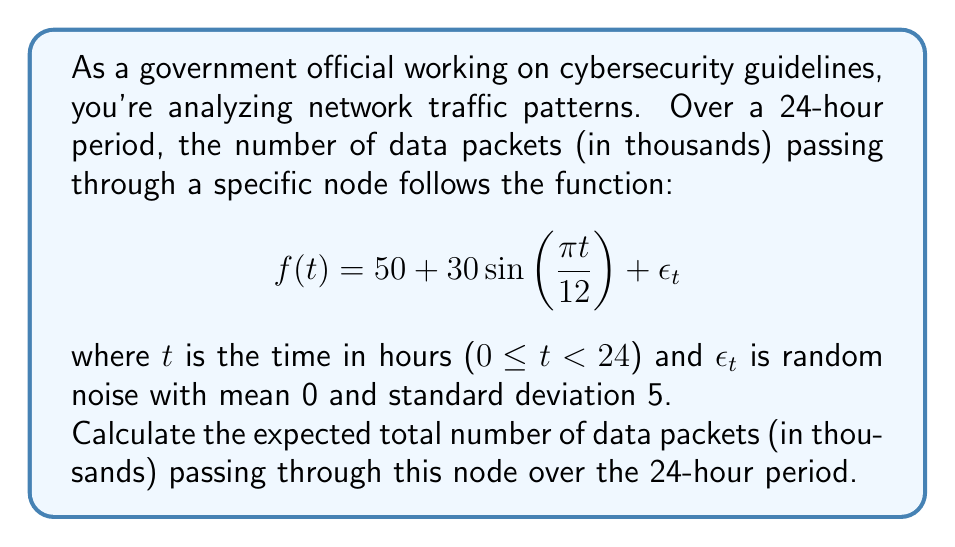Can you solve this math problem? To solve this problem, we need to integrate the function $f(t)$ over the 24-hour period, excluding the random noise term $\epsilon_t$ as its expected value is 0.

1) First, let's consider the integral of $f(t)$ without the noise term:

   $$\int_0^{24} (50 + 30\sin(\frac{\pi t}{12})) dt$$

2) We can split this into two integrals:

   $$\int_0^{24} 50 dt + \int_0^{24} 30\sin(\frac{\pi t}{12}) dt$$

3) The first integral is straightforward:

   $$50 \cdot 24 = 1200$$

4) For the second integral, we use the substitution $u = \frac{\pi t}{12}$:

   $$\frac{360}{\pi} \int_0^{2\pi} \sin(u) du$$

5) We know that $\int \sin(u) du = -\cos(u) + C$, so:

   $$\frac{360}{\pi} [-\cos(u)]_0^{2\pi} = \frac{360}{\pi} [-\cos(2\pi) + \cos(0)] = 0$$

6) Therefore, the total integral is simply 1200.

This means the expected number of data packets over the 24-hour period is 1,200,000.
Answer: 1,200,000 data packets 